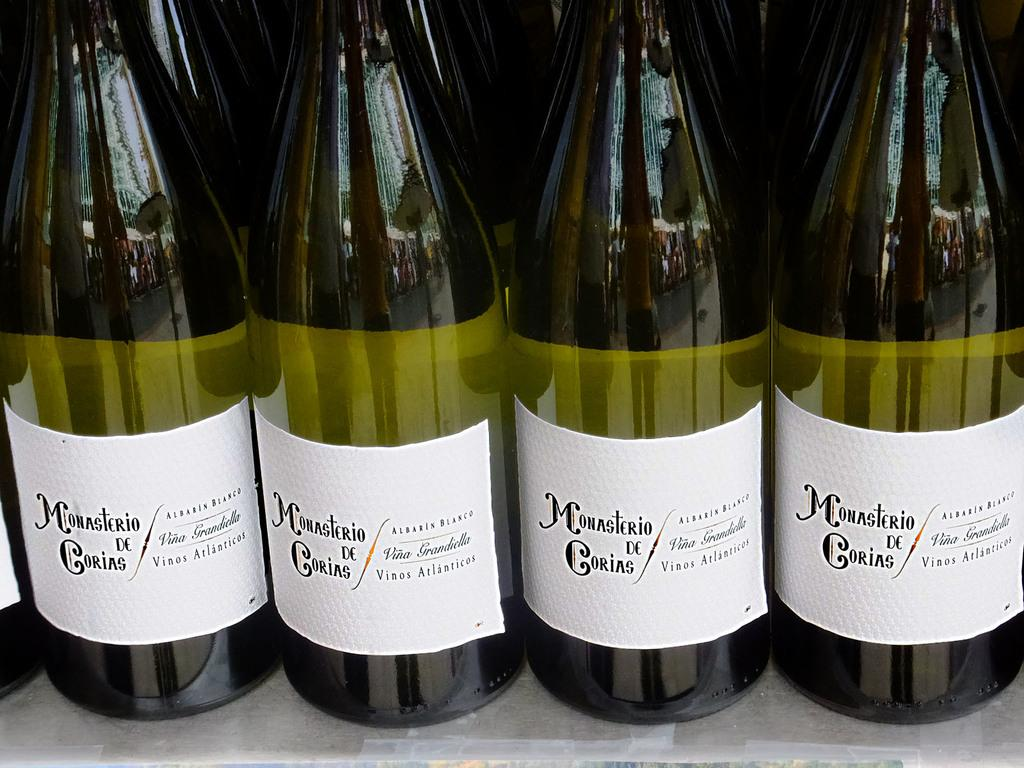<image>
Offer a succinct explanation of the picture presented. Alcohol bottle with a label that says "Monasterio de Corias". 